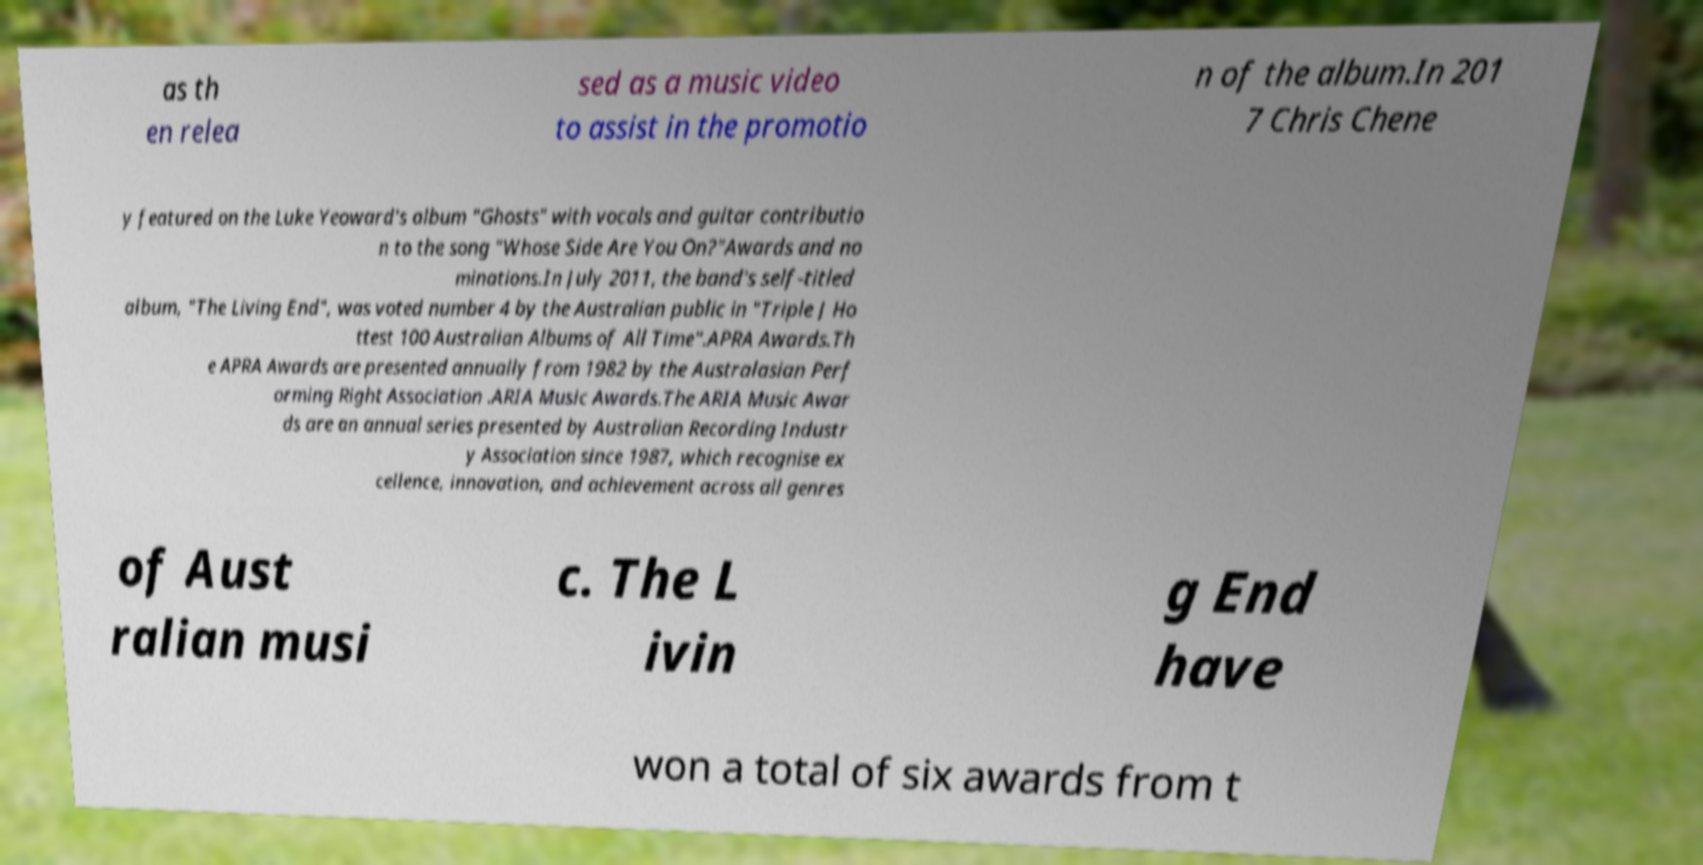I need the written content from this picture converted into text. Can you do that? as th en relea sed as a music video to assist in the promotio n of the album.In 201 7 Chris Chene y featured on the Luke Yeoward's album "Ghosts" with vocals and guitar contributio n to the song "Whose Side Are You On?"Awards and no minations.In July 2011, the band's self-titled album, "The Living End", was voted number 4 by the Australian public in "Triple J Ho ttest 100 Australian Albums of All Time".APRA Awards.Th e APRA Awards are presented annually from 1982 by the Australasian Perf orming Right Association .ARIA Music Awards.The ARIA Music Awar ds are an annual series presented by Australian Recording Industr y Association since 1987, which recognise ex cellence, innovation, and achievement across all genres of Aust ralian musi c. The L ivin g End have won a total of six awards from t 